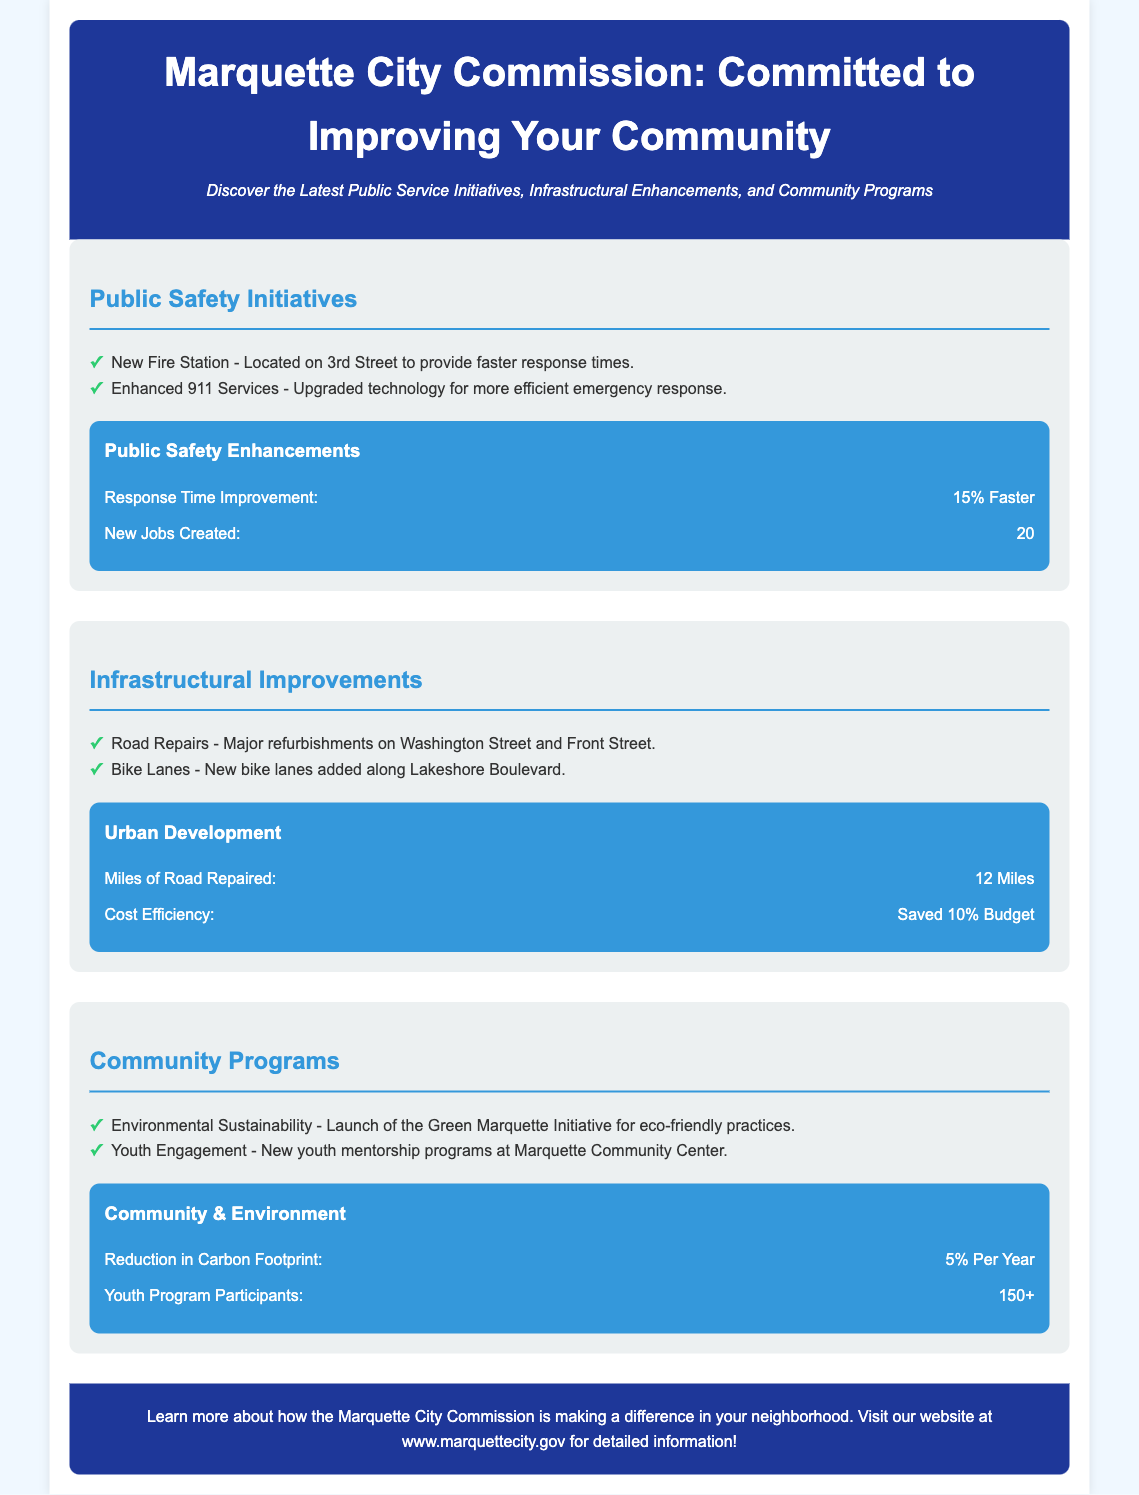What is the location of the new fire station? The document states that the new fire station is located on 3rd Street.
Answer: 3rd Street How much faster is the response time for emergency services? The document indicates that the response time improvement is 15% faster.
Answer: 15% Faster What is the total number of new jobs created? The document specifies that 20 new jobs have been created.
Answer: 20 How many miles of road were repaired? According to the document, 12 miles of road were repaired.
Answer: 12 Miles What budget savings percentage is mentioned in the infrastructural improvements? The document mentions a saved budget of 10%.
Answer: 10% Budget What is the name of the environmental initiative launched? The document refers to the Green Marquette Initiative.
Answer: Green Marquette Initiative How many youth program participants were reported? The document states that there are 150+ youth program participants.
Answer: 150+ What major street underwent repairs? The document lists Washington Street and Front Street as major streets that underwent repairs.
Answer: Washington Street and Front Street What specific technology was upgraded for emergency services? The document refers to enhanced 911 services technology for more efficient emergency response.
Answer: Enhanced 911 Services 